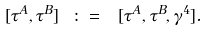Convert formula to latex. <formula><loc_0><loc_0><loc_500><loc_500>[ \tau ^ { A } , \tau ^ { B } ] \ \colon = \ [ \tau ^ { A } , \tau ^ { B } , \gamma ^ { 4 } ] .</formula> 